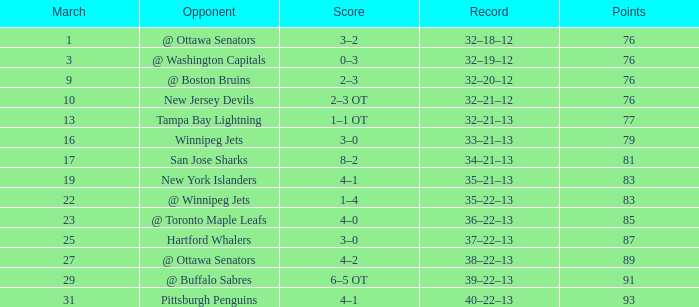How much March has Points of 85? 1.0. 